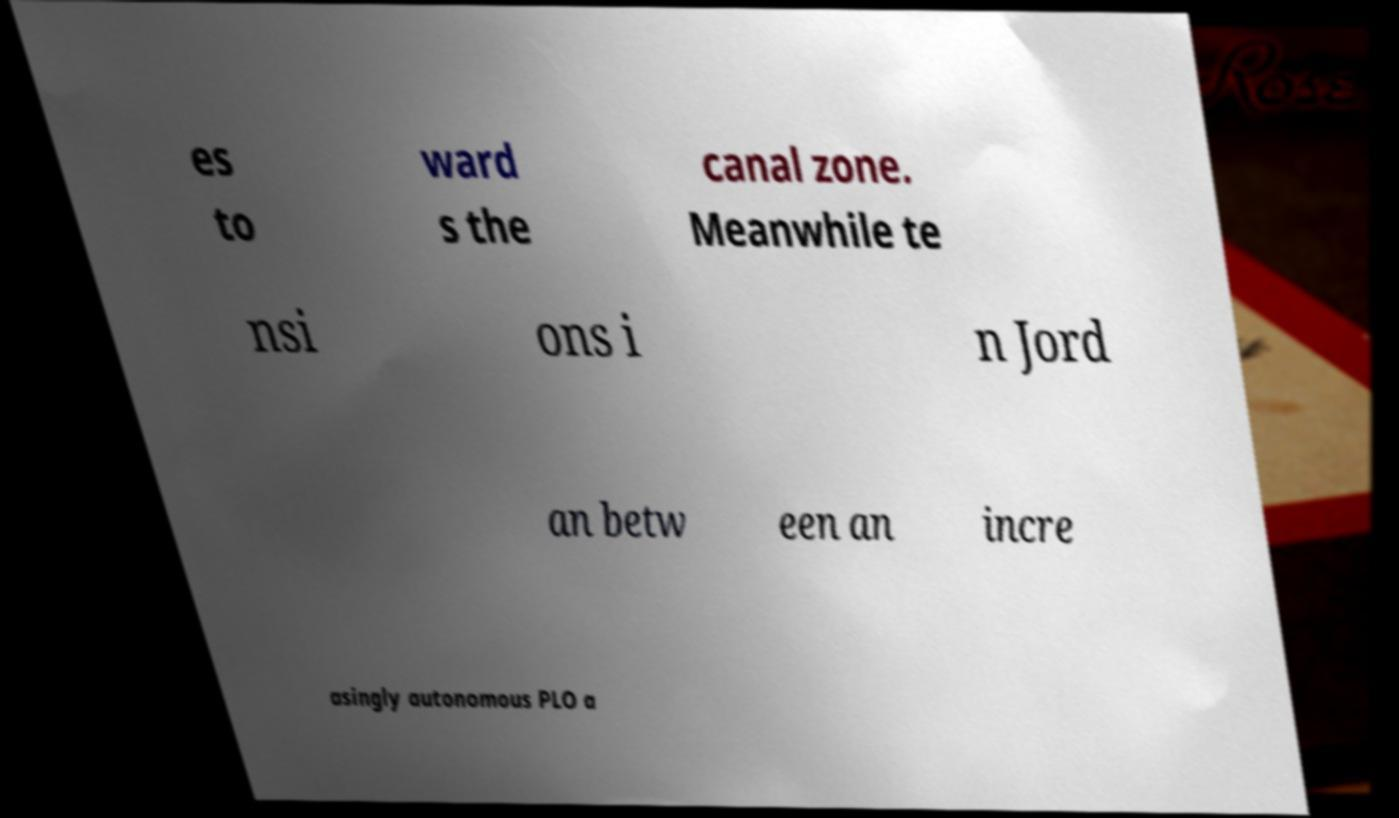For documentation purposes, I need the text within this image transcribed. Could you provide that? es to ward s the canal zone. Meanwhile te nsi ons i n Jord an betw een an incre asingly autonomous PLO a 